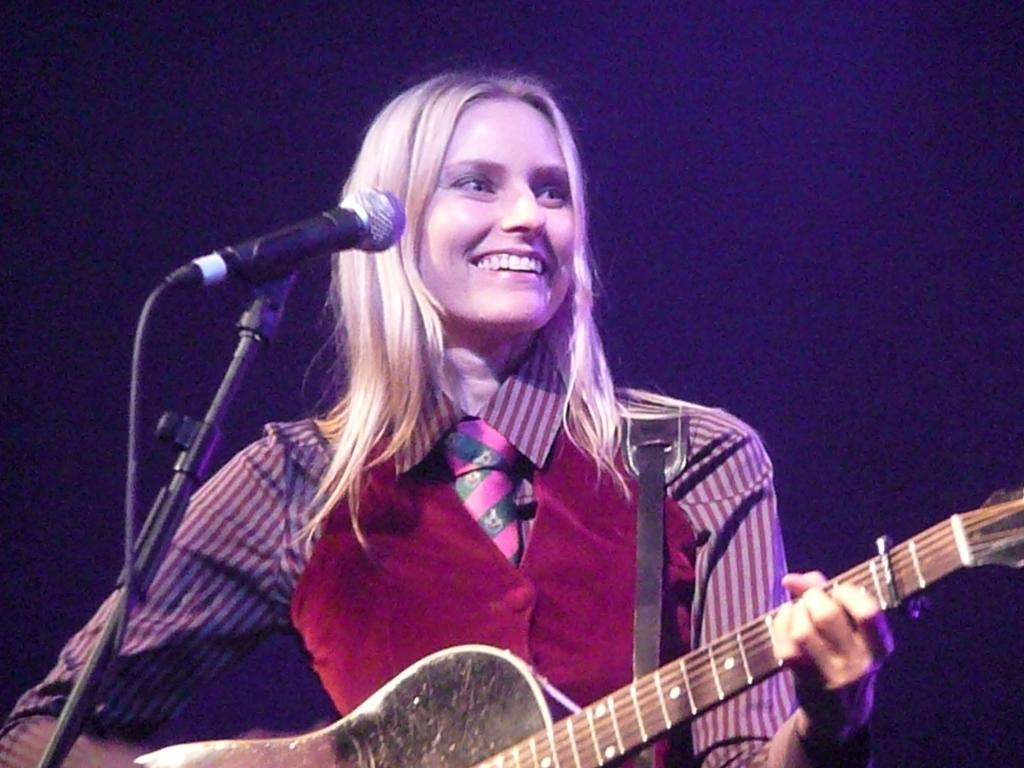Who is the main subject in the image? There is a woman in the image. What is the woman doing in the image? The woman is playing the guitar. How can we tell that the woman is enjoying herself? The woman is smiling in the image. What object is in front of the woman? There is a microphone (mic) in front of the woman. How many ants can be seen crawling on the guitar in the image? There are no ants visible in the image, and therefore no such activity can be observed. 